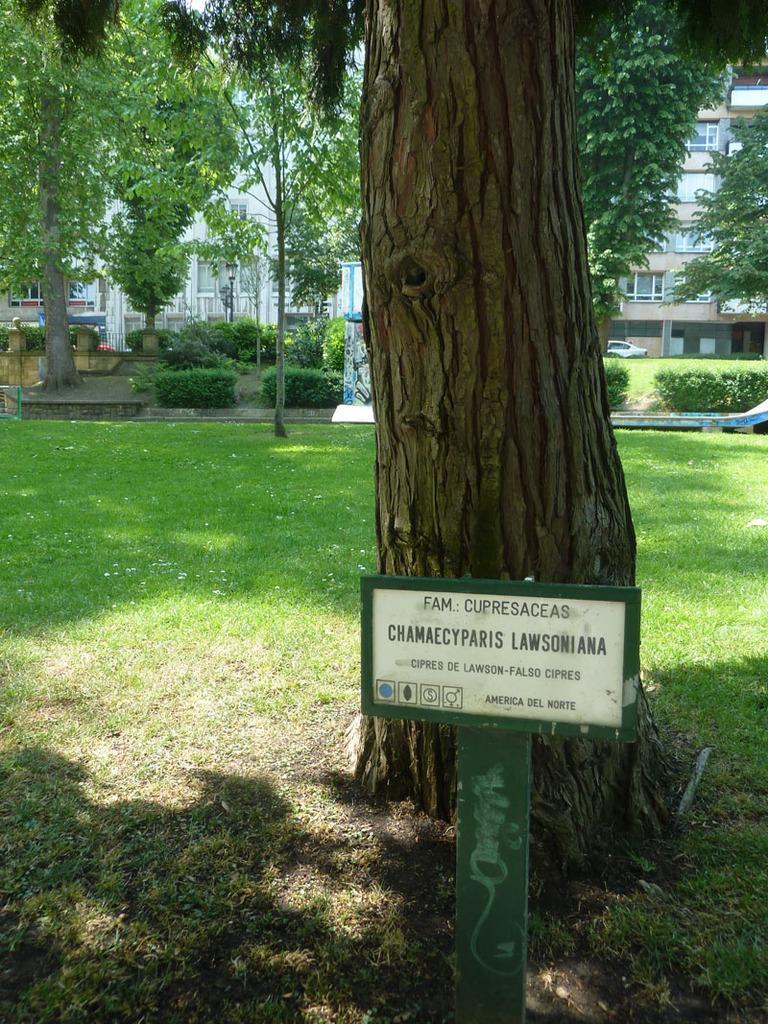How would you summarize this image in a sentence or two? In this image we can see a board, grassland, trees, light poles, a car parked here and the buildings in the background. 